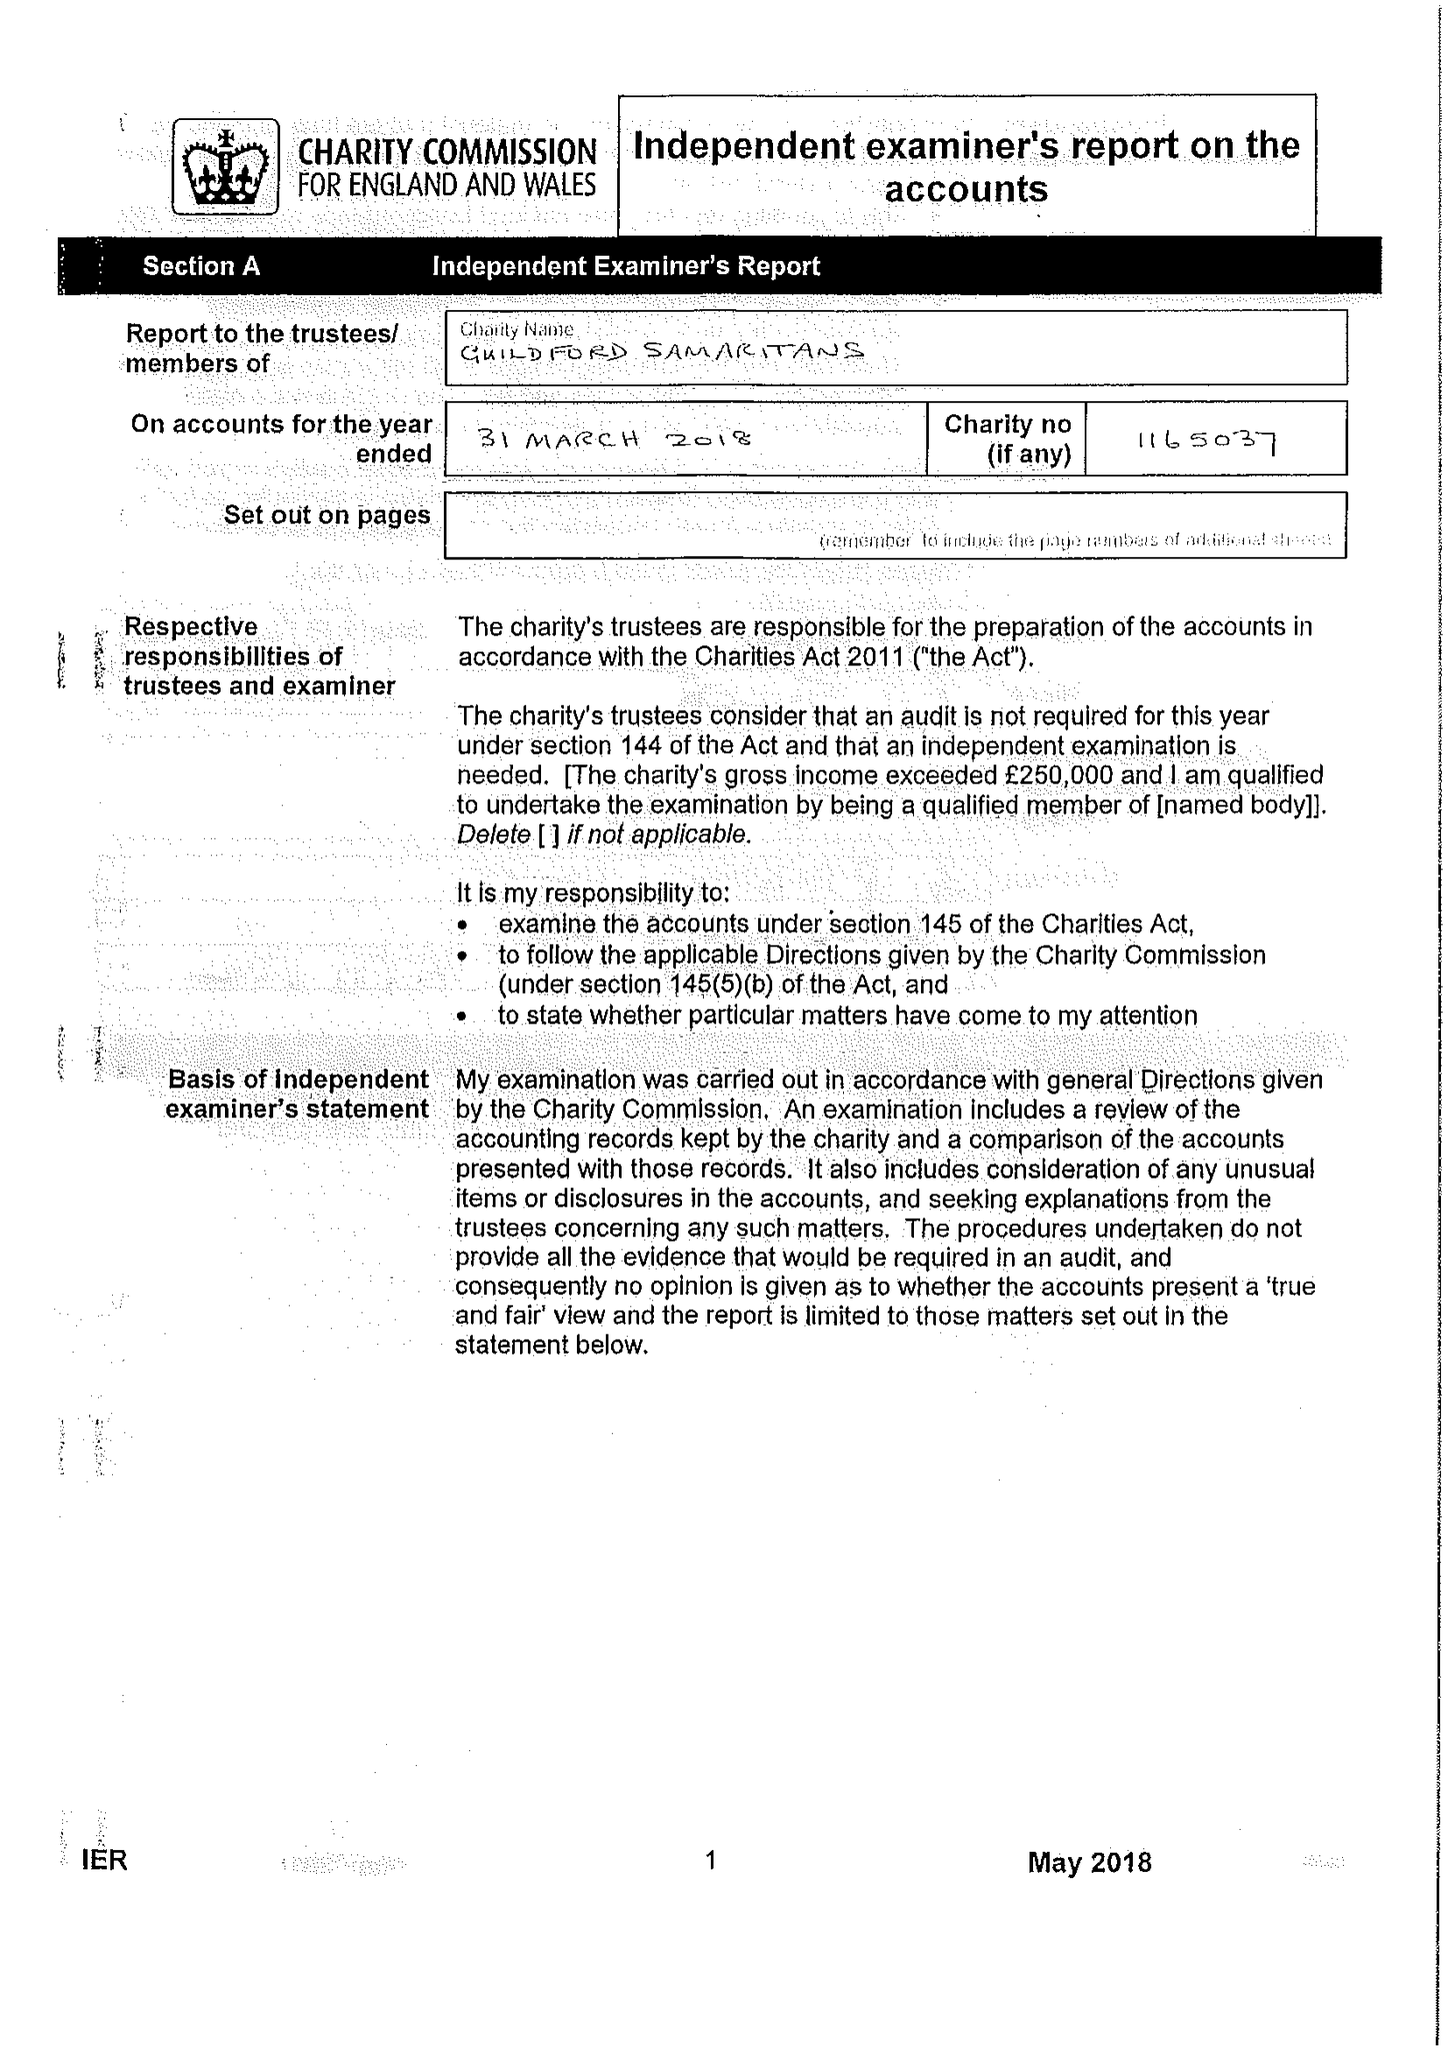What is the value for the income_annually_in_british_pounds?
Answer the question using a single word or phrase. 93043.00 